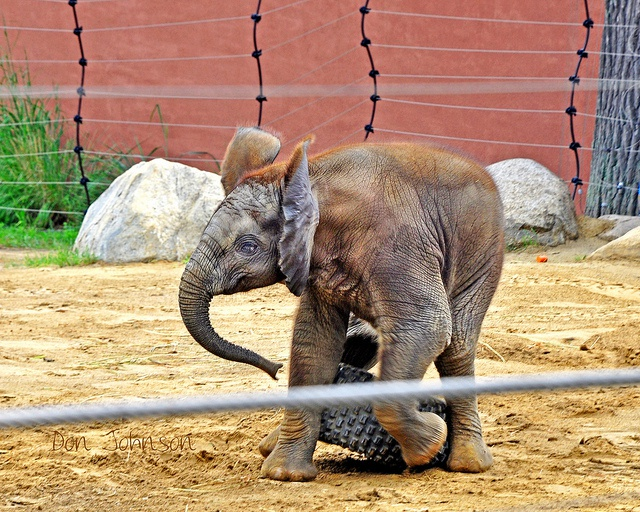Describe the objects in this image and their specific colors. I can see a elephant in salmon, gray, darkgray, and tan tones in this image. 